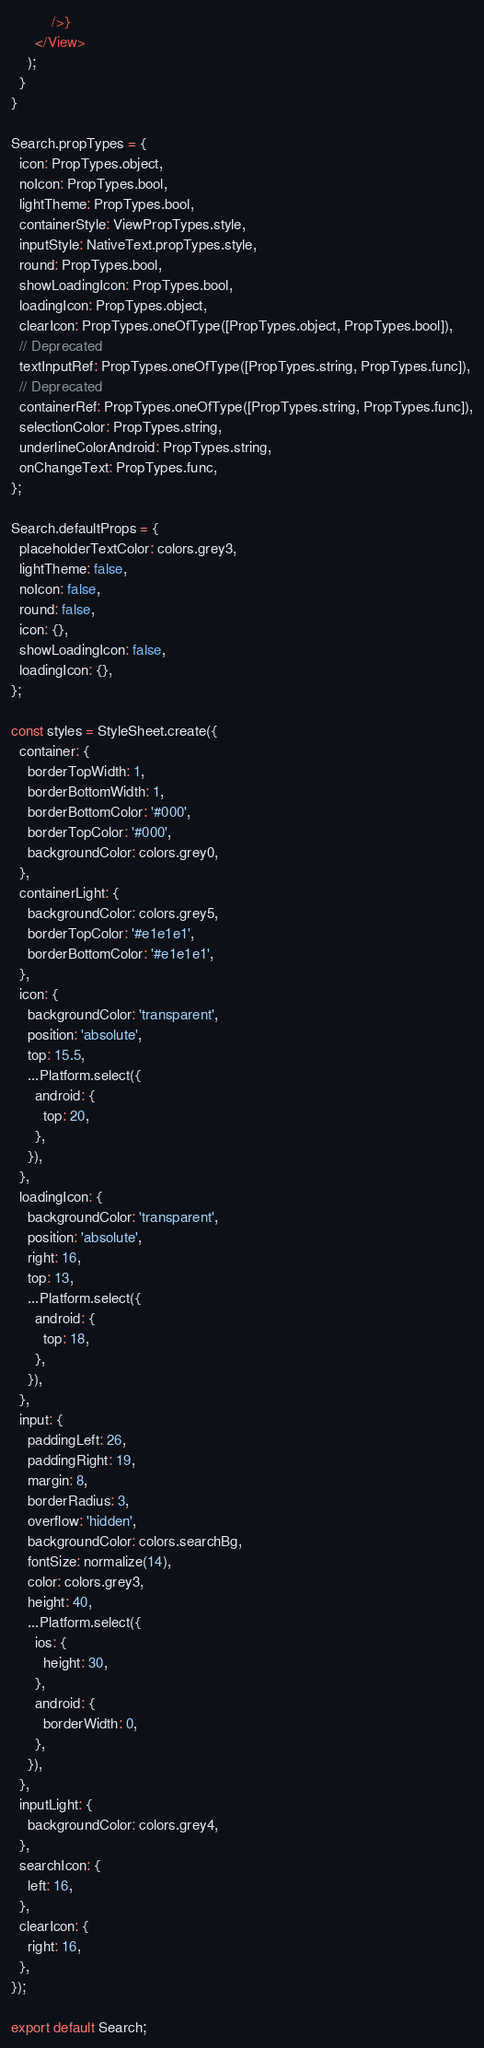<code> <loc_0><loc_0><loc_500><loc_500><_JavaScript_>          />}
      </View>
    );
  }
}

Search.propTypes = {
  icon: PropTypes.object,
  noIcon: PropTypes.bool,
  lightTheme: PropTypes.bool,
  containerStyle: ViewPropTypes.style,
  inputStyle: NativeText.propTypes.style,
  round: PropTypes.bool,
  showLoadingIcon: PropTypes.bool,
  loadingIcon: PropTypes.object,
  clearIcon: PropTypes.oneOfType([PropTypes.object, PropTypes.bool]),
  // Deprecated
  textInputRef: PropTypes.oneOfType([PropTypes.string, PropTypes.func]),
  // Deprecated
  containerRef: PropTypes.oneOfType([PropTypes.string, PropTypes.func]),
  selectionColor: PropTypes.string,
  underlineColorAndroid: PropTypes.string,
  onChangeText: PropTypes.func,
};

Search.defaultProps = {
  placeholderTextColor: colors.grey3,
  lightTheme: false,
  noIcon: false,
  round: false,
  icon: {},
  showLoadingIcon: false,
  loadingIcon: {},
};

const styles = StyleSheet.create({
  container: {
    borderTopWidth: 1,
    borderBottomWidth: 1,
    borderBottomColor: '#000',
    borderTopColor: '#000',
    backgroundColor: colors.grey0,
  },
  containerLight: {
    backgroundColor: colors.grey5,
    borderTopColor: '#e1e1e1',
    borderBottomColor: '#e1e1e1',
  },
  icon: {
    backgroundColor: 'transparent',
    position: 'absolute',
    top: 15.5,
    ...Platform.select({
      android: {
        top: 20,
      },
    }),
  },
  loadingIcon: {
    backgroundColor: 'transparent',
    position: 'absolute',
    right: 16,
    top: 13,
    ...Platform.select({
      android: {
        top: 18,
      },
    }),
  },
  input: {
    paddingLeft: 26,
    paddingRight: 19,
    margin: 8,
    borderRadius: 3,
    overflow: 'hidden',
    backgroundColor: colors.searchBg,
    fontSize: normalize(14),
    color: colors.grey3,
    height: 40,
    ...Platform.select({
      ios: {
        height: 30,
      },
      android: {
        borderWidth: 0,
      },
    }),
  },
  inputLight: {
    backgroundColor: colors.grey4,
  },
  searchIcon: {
    left: 16,
  },
  clearIcon: {
    right: 16,
  },
});

export default Search;
</code> 